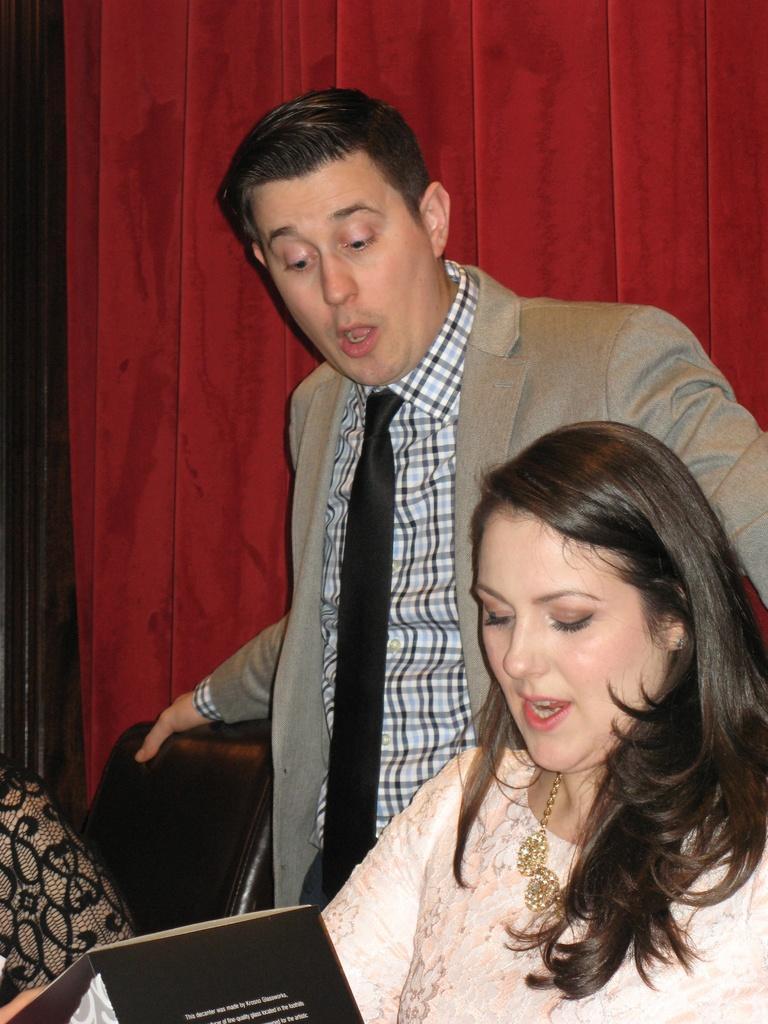Please provide a concise description of this image. In the picture we can see a man and a woman, a man is standing and holding a chair and a woman is holding a magazine and watching it and in the background we can see the wall. 